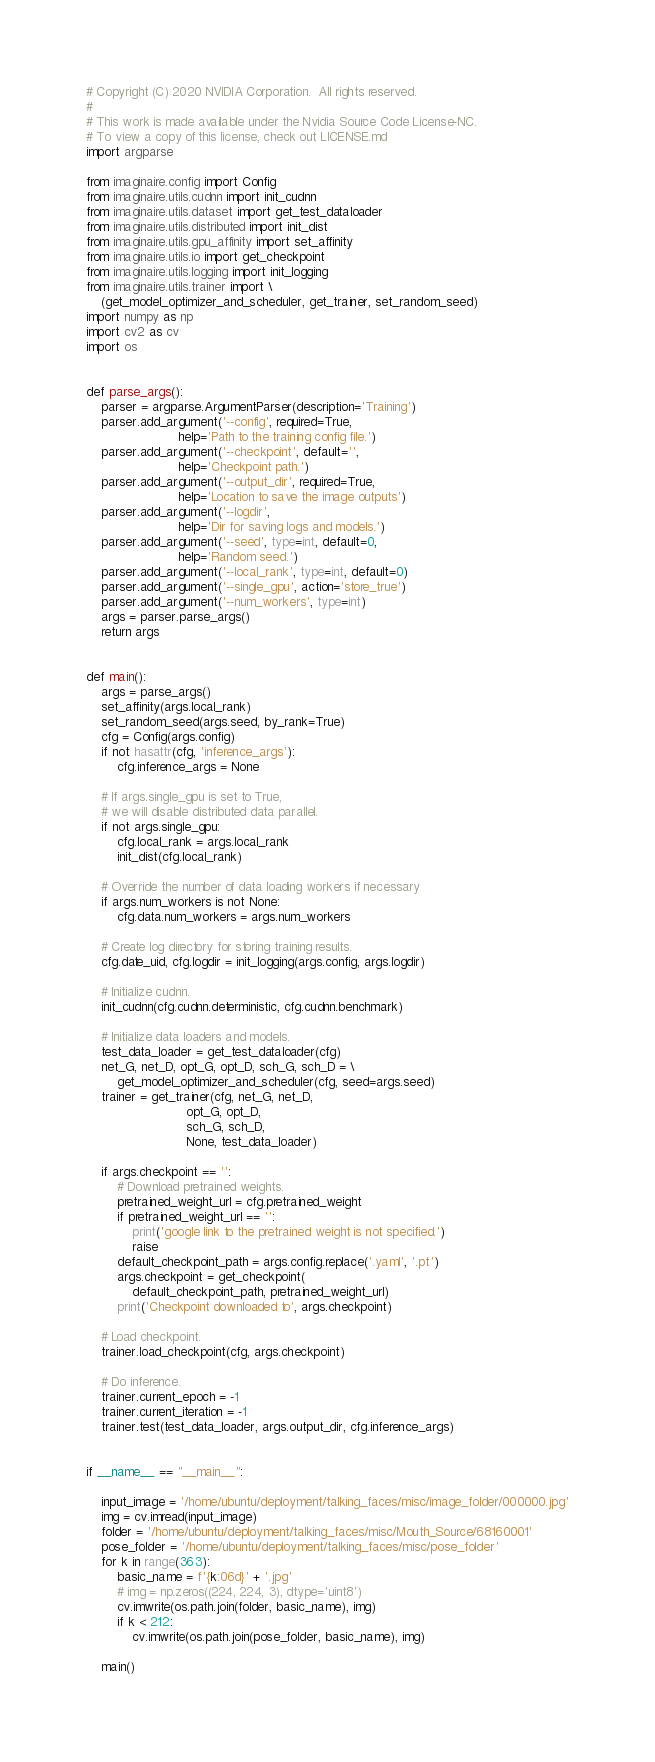Convert code to text. <code><loc_0><loc_0><loc_500><loc_500><_Python_># Copyright (C) 2020 NVIDIA Corporation.  All rights reserved.
#
# This work is made available under the Nvidia Source Code License-NC.
# To view a copy of this license, check out LICENSE.md
import argparse

from imaginaire.config import Config
from imaginaire.utils.cudnn import init_cudnn
from imaginaire.utils.dataset import get_test_dataloader
from imaginaire.utils.distributed import init_dist
from imaginaire.utils.gpu_affinity import set_affinity
from imaginaire.utils.io import get_checkpoint
from imaginaire.utils.logging import init_logging
from imaginaire.utils.trainer import \
    (get_model_optimizer_and_scheduler, get_trainer, set_random_seed)
import numpy as np
import cv2 as cv
import os


def parse_args():
    parser = argparse.ArgumentParser(description='Training')
    parser.add_argument('--config', required=True,
                        help='Path to the training config file.')
    parser.add_argument('--checkpoint', default='',
                        help='Checkpoint path.')
    parser.add_argument('--output_dir', required=True,
                        help='Location to save the image outputs')
    parser.add_argument('--logdir',
                        help='Dir for saving logs and models.')
    parser.add_argument('--seed', type=int, default=0,
                        help='Random seed.')
    parser.add_argument('--local_rank', type=int, default=0)
    parser.add_argument('--single_gpu', action='store_true')
    parser.add_argument('--num_workers', type=int)
    args = parser.parse_args()
    return args


def main():
    args = parse_args()
    set_affinity(args.local_rank)
    set_random_seed(args.seed, by_rank=True)
    cfg = Config(args.config)
    if not hasattr(cfg, 'inference_args'):
        cfg.inference_args = None

    # If args.single_gpu is set to True,
    # we will disable distributed data parallel.
    if not args.single_gpu:
        cfg.local_rank = args.local_rank
        init_dist(cfg.local_rank)

    # Override the number of data loading workers if necessary
    if args.num_workers is not None:
        cfg.data.num_workers = args.num_workers

    # Create log directory for storing training results.
    cfg.date_uid, cfg.logdir = init_logging(args.config, args.logdir)

    # Initialize cudnn.
    init_cudnn(cfg.cudnn.deterministic, cfg.cudnn.benchmark)

    # Initialize data loaders and models.
    test_data_loader = get_test_dataloader(cfg)
    net_G, net_D, opt_G, opt_D, sch_G, sch_D = \
        get_model_optimizer_and_scheduler(cfg, seed=args.seed)
    trainer = get_trainer(cfg, net_G, net_D,
                          opt_G, opt_D,
                          sch_G, sch_D,
                          None, test_data_loader)

    if args.checkpoint == '':
        # Download pretrained weights.
        pretrained_weight_url = cfg.pretrained_weight
        if pretrained_weight_url == '':
            print('google link to the pretrained weight is not specified.')
            raise
        default_checkpoint_path = args.config.replace('.yaml', '.pt')
        args.checkpoint = get_checkpoint(
            default_checkpoint_path, pretrained_weight_url)
        print('Checkpoint downloaded to', args.checkpoint)

    # Load checkpoint.
    trainer.load_checkpoint(cfg, args.checkpoint)

    # Do inference.
    trainer.current_epoch = -1
    trainer.current_iteration = -1
    trainer.test(test_data_loader, args.output_dir, cfg.inference_args)


if __name__ == "__main__":

    input_image = '/home/ubuntu/deployment/talking_faces/misc/image_folder/000000.jpg'
    img = cv.imread(input_image)
    folder = '/home/ubuntu/deployment/talking_faces/misc/Mouth_Source/68160001'
    pose_folder = '/home/ubuntu/deployment/talking_faces/misc/pose_folder'
    for k in range(363):
        basic_name = f'{k:06d}' + '.jpg'
        # img = np.zeros((224, 224, 3), dtype='uint8')
        cv.imwrite(os.path.join(folder, basic_name), img)
        if k < 212:
            cv.imwrite(os.path.join(pose_folder, basic_name), img)

    main()
</code> 